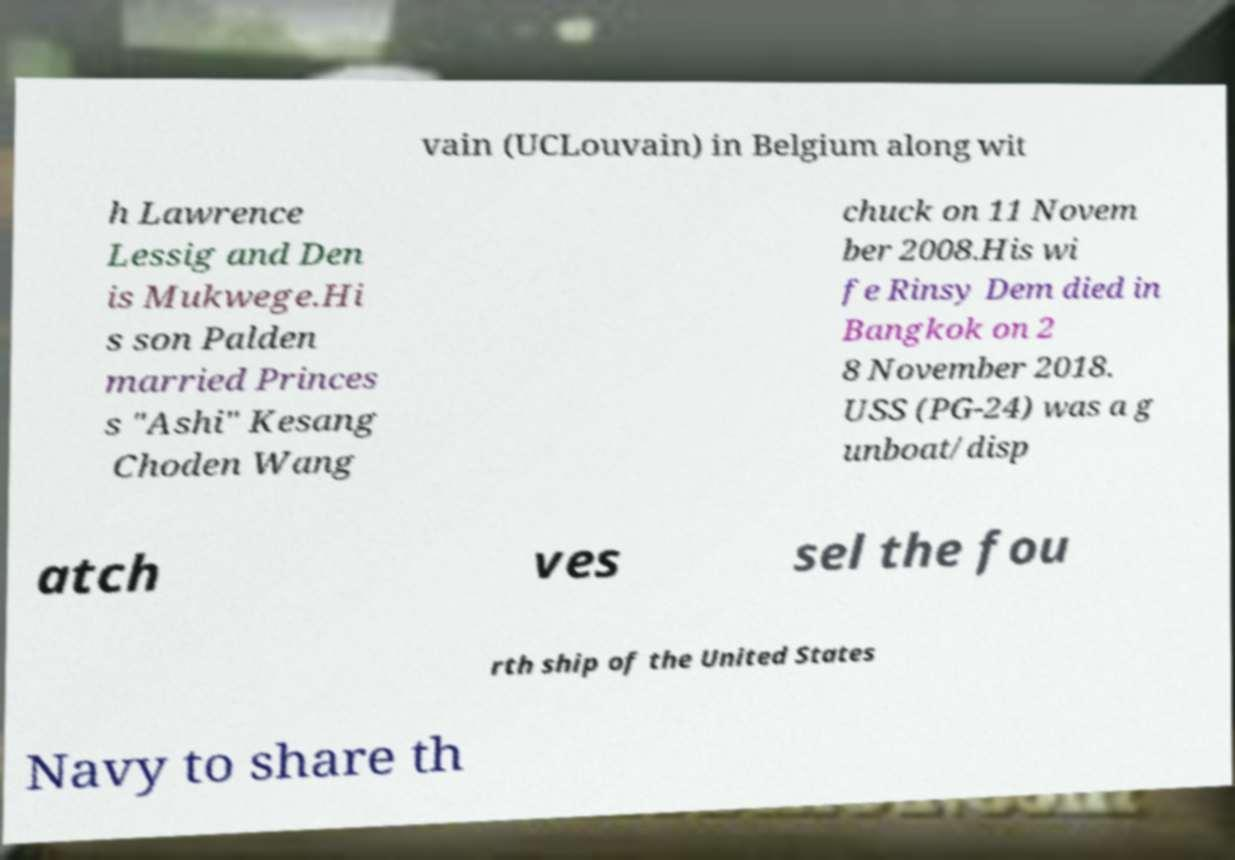Could you extract and type out the text from this image? vain (UCLouvain) in Belgium along wit h Lawrence Lessig and Den is Mukwege.Hi s son Palden married Princes s "Ashi" Kesang Choden Wang chuck on 11 Novem ber 2008.His wi fe Rinsy Dem died in Bangkok on 2 8 November 2018. USS (PG-24) was a g unboat/disp atch ves sel the fou rth ship of the United States Navy to share th 